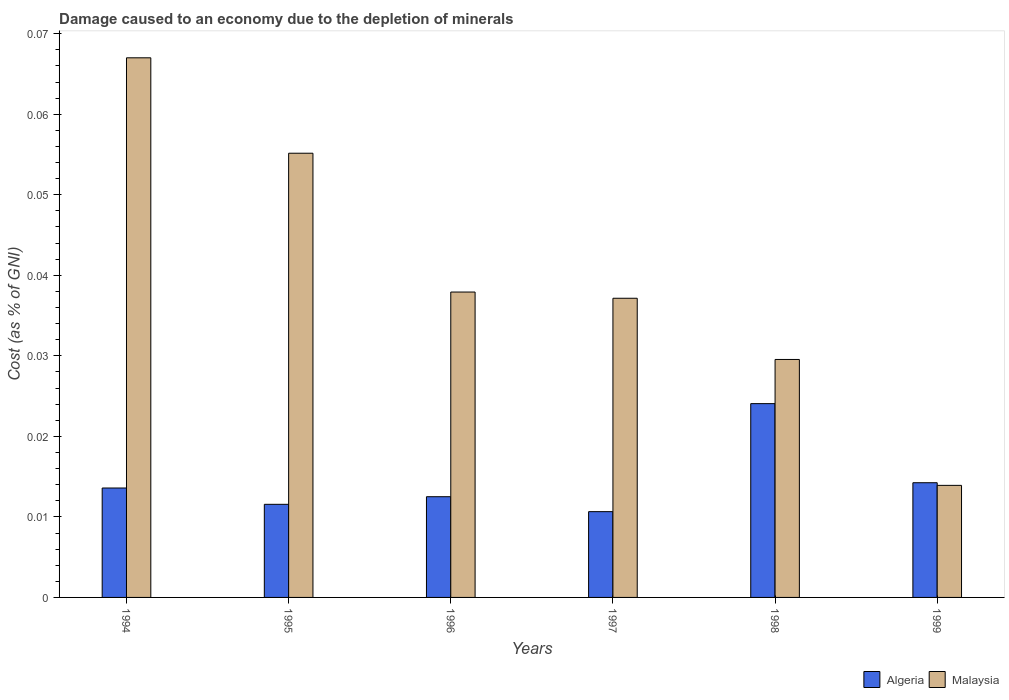How many groups of bars are there?
Your response must be concise. 6. How many bars are there on the 6th tick from the right?
Your answer should be compact. 2. What is the cost of damage caused due to the depletion of minerals in Malaysia in 1996?
Ensure brevity in your answer.  0.04. Across all years, what is the maximum cost of damage caused due to the depletion of minerals in Malaysia?
Offer a terse response. 0.07. Across all years, what is the minimum cost of damage caused due to the depletion of minerals in Algeria?
Offer a terse response. 0.01. What is the total cost of damage caused due to the depletion of minerals in Malaysia in the graph?
Provide a succinct answer. 0.24. What is the difference between the cost of damage caused due to the depletion of minerals in Algeria in 1995 and that in 1997?
Offer a very short reply. 0. What is the difference between the cost of damage caused due to the depletion of minerals in Malaysia in 1997 and the cost of damage caused due to the depletion of minerals in Algeria in 1994?
Your response must be concise. 0.02. What is the average cost of damage caused due to the depletion of minerals in Algeria per year?
Offer a very short reply. 0.01. In the year 1998, what is the difference between the cost of damage caused due to the depletion of minerals in Malaysia and cost of damage caused due to the depletion of minerals in Algeria?
Provide a succinct answer. 0.01. In how many years, is the cost of damage caused due to the depletion of minerals in Malaysia greater than 0.03 %?
Offer a very short reply. 4. What is the ratio of the cost of damage caused due to the depletion of minerals in Malaysia in 1995 to that in 1996?
Provide a succinct answer. 1.45. Is the cost of damage caused due to the depletion of minerals in Algeria in 1997 less than that in 1999?
Keep it short and to the point. Yes. What is the difference between the highest and the second highest cost of damage caused due to the depletion of minerals in Algeria?
Provide a short and direct response. 0.01. What is the difference between the highest and the lowest cost of damage caused due to the depletion of minerals in Malaysia?
Ensure brevity in your answer.  0.05. Is the sum of the cost of damage caused due to the depletion of minerals in Algeria in 1997 and 1999 greater than the maximum cost of damage caused due to the depletion of minerals in Malaysia across all years?
Offer a terse response. No. What does the 1st bar from the left in 1994 represents?
Provide a succinct answer. Algeria. What does the 2nd bar from the right in 1998 represents?
Ensure brevity in your answer.  Algeria. Are all the bars in the graph horizontal?
Your answer should be very brief. No. What is the difference between two consecutive major ticks on the Y-axis?
Keep it short and to the point. 0.01. How are the legend labels stacked?
Your answer should be compact. Horizontal. What is the title of the graph?
Offer a terse response. Damage caused to an economy due to the depletion of minerals. Does "Yemen, Rep." appear as one of the legend labels in the graph?
Your answer should be compact. No. What is the label or title of the X-axis?
Your answer should be compact. Years. What is the label or title of the Y-axis?
Provide a succinct answer. Cost (as % of GNI). What is the Cost (as % of GNI) of Algeria in 1994?
Your answer should be very brief. 0.01. What is the Cost (as % of GNI) in Malaysia in 1994?
Provide a short and direct response. 0.07. What is the Cost (as % of GNI) of Algeria in 1995?
Ensure brevity in your answer.  0.01. What is the Cost (as % of GNI) of Malaysia in 1995?
Make the answer very short. 0.06. What is the Cost (as % of GNI) of Algeria in 1996?
Give a very brief answer. 0.01. What is the Cost (as % of GNI) in Malaysia in 1996?
Your answer should be very brief. 0.04. What is the Cost (as % of GNI) in Algeria in 1997?
Keep it short and to the point. 0.01. What is the Cost (as % of GNI) in Malaysia in 1997?
Provide a short and direct response. 0.04. What is the Cost (as % of GNI) of Algeria in 1998?
Your answer should be compact. 0.02. What is the Cost (as % of GNI) of Malaysia in 1998?
Keep it short and to the point. 0.03. What is the Cost (as % of GNI) in Algeria in 1999?
Provide a succinct answer. 0.01. What is the Cost (as % of GNI) in Malaysia in 1999?
Your response must be concise. 0.01. Across all years, what is the maximum Cost (as % of GNI) of Algeria?
Make the answer very short. 0.02. Across all years, what is the maximum Cost (as % of GNI) in Malaysia?
Ensure brevity in your answer.  0.07. Across all years, what is the minimum Cost (as % of GNI) of Algeria?
Your answer should be very brief. 0.01. Across all years, what is the minimum Cost (as % of GNI) in Malaysia?
Make the answer very short. 0.01. What is the total Cost (as % of GNI) of Algeria in the graph?
Offer a very short reply. 0.09. What is the total Cost (as % of GNI) in Malaysia in the graph?
Your response must be concise. 0.24. What is the difference between the Cost (as % of GNI) of Algeria in 1994 and that in 1995?
Offer a terse response. 0. What is the difference between the Cost (as % of GNI) in Malaysia in 1994 and that in 1995?
Offer a terse response. 0.01. What is the difference between the Cost (as % of GNI) in Algeria in 1994 and that in 1996?
Provide a succinct answer. 0. What is the difference between the Cost (as % of GNI) of Malaysia in 1994 and that in 1996?
Offer a very short reply. 0.03. What is the difference between the Cost (as % of GNI) in Algeria in 1994 and that in 1997?
Provide a succinct answer. 0. What is the difference between the Cost (as % of GNI) in Malaysia in 1994 and that in 1997?
Offer a terse response. 0.03. What is the difference between the Cost (as % of GNI) of Algeria in 1994 and that in 1998?
Your response must be concise. -0.01. What is the difference between the Cost (as % of GNI) in Malaysia in 1994 and that in 1998?
Give a very brief answer. 0.04. What is the difference between the Cost (as % of GNI) in Algeria in 1994 and that in 1999?
Keep it short and to the point. -0. What is the difference between the Cost (as % of GNI) of Malaysia in 1994 and that in 1999?
Give a very brief answer. 0.05. What is the difference between the Cost (as % of GNI) in Algeria in 1995 and that in 1996?
Your response must be concise. -0. What is the difference between the Cost (as % of GNI) of Malaysia in 1995 and that in 1996?
Your answer should be very brief. 0.02. What is the difference between the Cost (as % of GNI) in Algeria in 1995 and that in 1997?
Provide a succinct answer. 0. What is the difference between the Cost (as % of GNI) in Malaysia in 1995 and that in 1997?
Ensure brevity in your answer.  0.02. What is the difference between the Cost (as % of GNI) of Algeria in 1995 and that in 1998?
Ensure brevity in your answer.  -0.01. What is the difference between the Cost (as % of GNI) in Malaysia in 1995 and that in 1998?
Your response must be concise. 0.03. What is the difference between the Cost (as % of GNI) of Algeria in 1995 and that in 1999?
Your response must be concise. -0. What is the difference between the Cost (as % of GNI) of Malaysia in 1995 and that in 1999?
Ensure brevity in your answer.  0.04. What is the difference between the Cost (as % of GNI) in Algeria in 1996 and that in 1997?
Your response must be concise. 0. What is the difference between the Cost (as % of GNI) in Malaysia in 1996 and that in 1997?
Provide a short and direct response. 0. What is the difference between the Cost (as % of GNI) of Algeria in 1996 and that in 1998?
Your answer should be compact. -0.01. What is the difference between the Cost (as % of GNI) of Malaysia in 1996 and that in 1998?
Give a very brief answer. 0.01. What is the difference between the Cost (as % of GNI) in Algeria in 1996 and that in 1999?
Offer a terse response. -0. What is the difference between the Cost (as % of GNI) in Malaysia in 1996 and that in 1999?
Your answer should be compact. 0.02. What is the difference between the Cost (as % of GNI) in Algeria in 1997 and that in 1998?
Make the answer very short. -0.01. What is the difference between the Cost (as % of GNI) of Malaysia in 1997 and that in 1998?
Your answer should be compact. 0.01. What is the difference between the Cost (as % of GNI) in Algeria in 1997 and that in 1999?
Your answer should be compact. -0. What is the difference between the Cost (as % of GNI) in Malaysia in 1997 and that in 1999?
Offer a very short reply. 0.02. What is the difference between the Cost (as % of GNI) of Algeria in 1998 and that in 1999?
Provide a succinct answer. 0.01. What is the difference between the Cost (as % of GNI) of Malaysia in 1998 and that in 1999?
Make the answer very short. 0.02. What is the difference between the Cost (as % of GNI) of Algeria in 1994 and the Cost (as % of GNI) of Malaysia in 1995?
Offer a terse response. -0.04. What is the difference between the Cost (as % of GNI) of Algeria in 1994 and the Cost (as % of GNI) of Malaysia in 1996?
Make the answer very short. -0.02. What is the difference between the Cost (as % of GNI) in Algeria in 1994 and the Cost (as % of GNI) in Malaysia in 1997?
Offer a very short reply. -0.02. What is the difference between the Cost (as % of GNI) of Algeria in 1994 and the Cost (as % of GNI) of Malaysia in 1998?
Make the answer very short. -0.02. What is the difference between the Cost (as % of GNI) of Algeria in 1994 and the Cost (as % of GNI) of Malaysia in 1999?
Offer a very short reply. -0. What is the difference between the Cost (as % of GNI) in Algeria in 1995 and the Cost (as % of GNI) in Malaysia in 1996?
Your response must be concise. -0.03. What is the difference between the Cost (as % of GNI) in Algeria in 1995 and the Cost (as % of GNI) in Malaysia in 1997?
Offer a very short reply. -0.03. What is the difference between the Cost (as % of GNI) in Algeria in 1995 and the Cost (as % of GNI) in Malaysia in 1998?
Give a very brief answer. -0.02. What is the difference between the Cost (as % of GNI) of Algeria in 1995 and the Cost (as % of GNI) of Malaysia in 1999?
Your answer should be compact. -0. What is the difference between the Cost (as % of GNI) in Algeria in 1996 and the Cost (as % of GNI) in Malaysia in 1997?
Give a very brief answer. -0.02. What is the difference between the Cost (as % of GNI) in Algeria in 1996 and the Cost (as % of GNI) in Malaysia in 1998?
Provide a succinct answer. -0.02. What is the difference between the Cost (as % of GNI) of Algeria in 1996 and the Cost (as % of GNI) of Malaysia in 1999?
Your response must be concise. -0. What is the difference between the Cost (as % of GNI) of Algeria in 1997 and the Cost (as % of GNI) of Malaysia in 1998?
Give a very brief answer. -0.02. What is the difference between the Cost (as % of GNI) in Algeria in 1997 and the Cost (as % of GNI) in Malaysia in 1999?
Your answer should be very brief. -0. What is the difference between the Cost (as % of GNI) of Algeria in 1998 and the Cost (as % of GNI) of Malaysia in 1999?
Offer a terse response. 0.01. What is the average Cost (as % of GNI) of Algeria per year?
Offer a very short reply. 0.01. What is the average Cost (as % of GNI) of Malaysia per year?
Ensure brevity in your answer.  0.04. In the year 1994, what is the difference between the Cost (as % of GNI) in Algeria and Cost (as % of GNI) in Malaysia?
Give a very brief answer. -0.05. In the year 1995, what is the difference between the Cost (as % of GNI) of Algeria and Cost (as % of GNI) of Malaysia?
Offer a terse response. -0.04. In the year 1996, what is the difference between the Cost (as % of GNI) of Algeria and Cost (as % of GNI) of Malaysia?
Ensure brevity in your answer.  -0.03. In the year 1997, what is the difference between the Cost (as % of GNI) of Algeria and Cost (as % of GNI) of Malaysia?
Make the answer very short. -0.03. In the year 1998, what is the difference between the Cost (as % of GNI) of Algeria and Cost (as % of GNI) of Malaysia?
Make the answer very short. -0.01. What is the ratio of the Cost (as % of GNI) of Algeria in 1994 to that in 1995?
Offer a terse response. 1.18. What is the ratio of the Cost (as % of GNI) of Malaysia in 1994 to that in 1995?
Your answer should be compact. 1.21. What is the ratio of the Cost (as % of GNI) of Algeria in 1994 to that in 1996?
Provide a short and direct response. 1.09. What is the ratio of the Cost (as % of GNI) of Malaysia in 1994 to that in 1996?
Offer a terse response. 1.77. What is the ratio of the Cost (as % of GNI) in Algeria in 1994 to that in 1997?
Provide a short and direct response. 1.28. What is the ratio of the Cost (as % of GNI) of Malaysia in 1994 to that in 1997?
Give a very brief answer. 1.8. What is the ratio of the Cost (as % of GNI) of Algeria in 1994 to that in 1998?
Your answer should be very brief. 0.56. What is the ratio of the Cost (as % of GNI) of Malaysia in 1994 to that in 1998?
Offer a very short reply. 2.27. What is the ratio of the Cost (as % of GNI) of Algeria in 1994 to that in 1999?
Your answer should be very brief. 0.95. What is the ratio of the Cost (as % of GNI) in Malaysia in 1994 to that in 1999?
Offer a very short reply. 4.82. What is the ratio of the Cost (as % of GNI) of Algeria in 1995 to that in 1996?
Ensure brevity in your answer.  0.92. What is the ratio of the Cost (as % of GNI) of Malaysia in 1995 to that in 1996?
Your response must be concise. 1.45. What is the ratio of the Cost (as % of GNI) in Algeria in 1995 to that in 1997?
Ensure brevity in your answer.  1.09. What is the ratio of the Cost (as % of GNI) in Malaysia in 1995 to that in 1997?
Your answer should be compact. 1.48. What is the ratio of the Cost (as % of GNI) of Algeria in 1995 to that in 1998?
Your answer should be compact. 0.48. What is the ratio of the Cost (as % of GNI) in Malaysia in 1995 to that in 1998?
Your answer should be very brief. 1.87. What is the ratio of the Cost (as % of GNI) of Algeria in 1995 to that in 1999?
Your answer should be very brief. 0.81. What is the ratio of the Cost (as % of GNI) in Malaysia in 1995 to that in 1999?
Offer a terse response. 3.96. What is the ratio of the Cost (as % of GNI) in Algeria in 1996 to that in 1997?
Offer a terse response. 1.17. What is the ratio of the Cost (as % of GNI) of Malaysia in 1996 to that in 1997?
Your answer should be very brief. 1.02. What is the ratio of the Cost (as % of GNI) of Algeria in 1996 to that in 1998?
Provide a short and direct response. 0.52. What is the ratio of the Cost (as % of GNI) in Malaysia in 1996 to that in 1998?
Provide a succinct answer. 1.28. What is the ratio of the Cost (as % of GNI) of Algeria in 1996 to that in 1999?
Ensure brevity in your answer.  0.88. What is the ratio of the Cost (as % of GNI) in Malaysia in 1996 to that in 1999?
Offer a very short reply. 2.73. What is the ratio of the Cost (as % of GNI) in Algeria in 1997 to that in 1998?
Offer a terse response. 0.44. What is the ratio of the Cost (as % of GNI) of Malaysia in 1997 to that in 1998?
Your answer should be very brief. 1.26. What is the ratio of the Cost (as % of GNI) in Algeria in 1997 to that in 1999?
Provide a short and direct response. 0.75. What is the ratio of the Cost (as % of GNI) of Malaysia in 1997 to that in 1999?
Your answer should be compact. 2.67. What is the ratio of the Cost (as % of GNI) of Algeria in 1998 to that in 1999?
Provide a succinct answer. 1.69. What is the ratio of the Cost (as % of GNI) in Malaysia in 1998 to that in 1999?
Give a very brief answer. 2.12. What is the difference between the highest and the second highest Cost (as % of GNI) in Algeria?
Keep it short and to the point. 0.01. What is the difference between the highest and the second highest Cost (as % of GNI) in Malaysia?
Give a very brief answer. 0.01. What is the difference between the highest and the lowest Cost (as % of GNI) in Algeria?
Provide a short and direct response. 0.01. What is the difference between the highest and the lowest Cost (as % of GNI) in Malaysia?
Your answer should be compact. 0.05. 